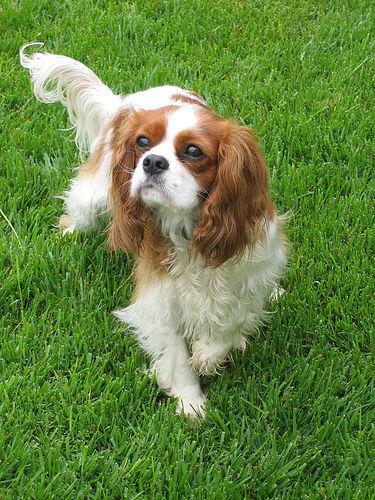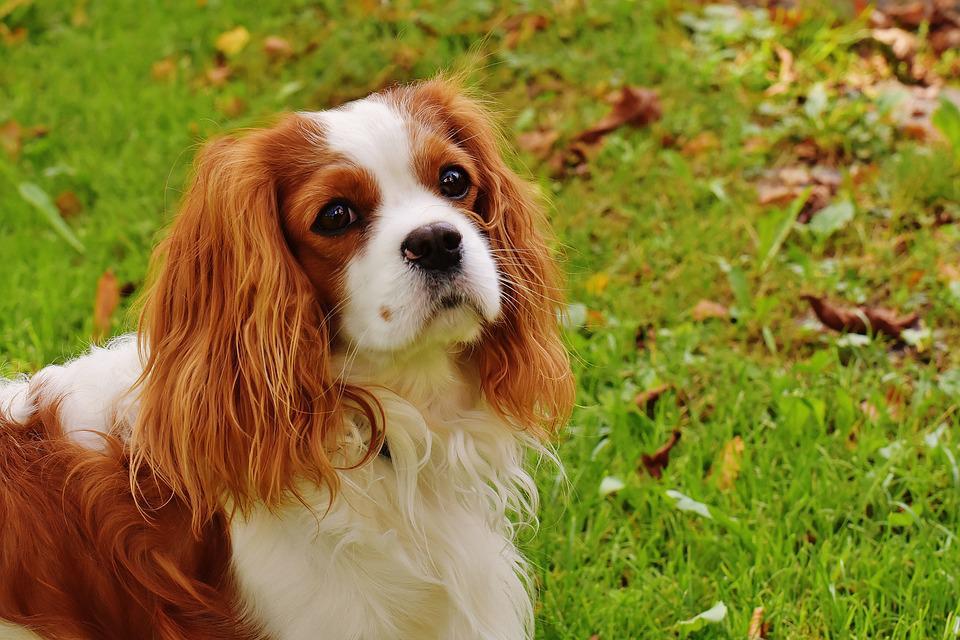The first image is the image on the left, the second image is the image on the right. For the images displayed, is the sentence "At least one image has no grass." factually correct? Answer yes or no. No. 